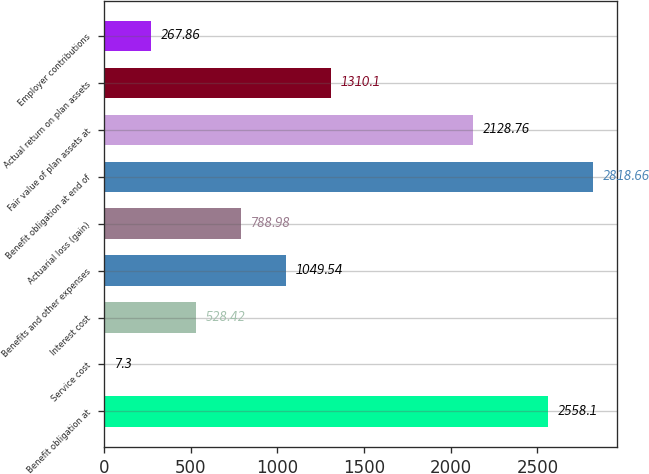<chart> <loc_0><loc_0><loc_500><loc_500><bar_chart><fcel>Benefit obligation at<fcel>Service cost<fcel>Interest cost<fcel>Benefits and other expenses<fcel>Actuarial loss (gain)<fcel>Benefit obligation at end of<fcel>Fair value of plan assets at<fcel>Actual return on plan assets<fcel>Employer contributions<nl><fcel>2558.1<fcel>7.3<fcel>528.42<fcel>1049.54<fcel>788.98<fcel>2818.66<fcel>2128.76<fcel>1310.1<fcel>267.86<nl></chart> 